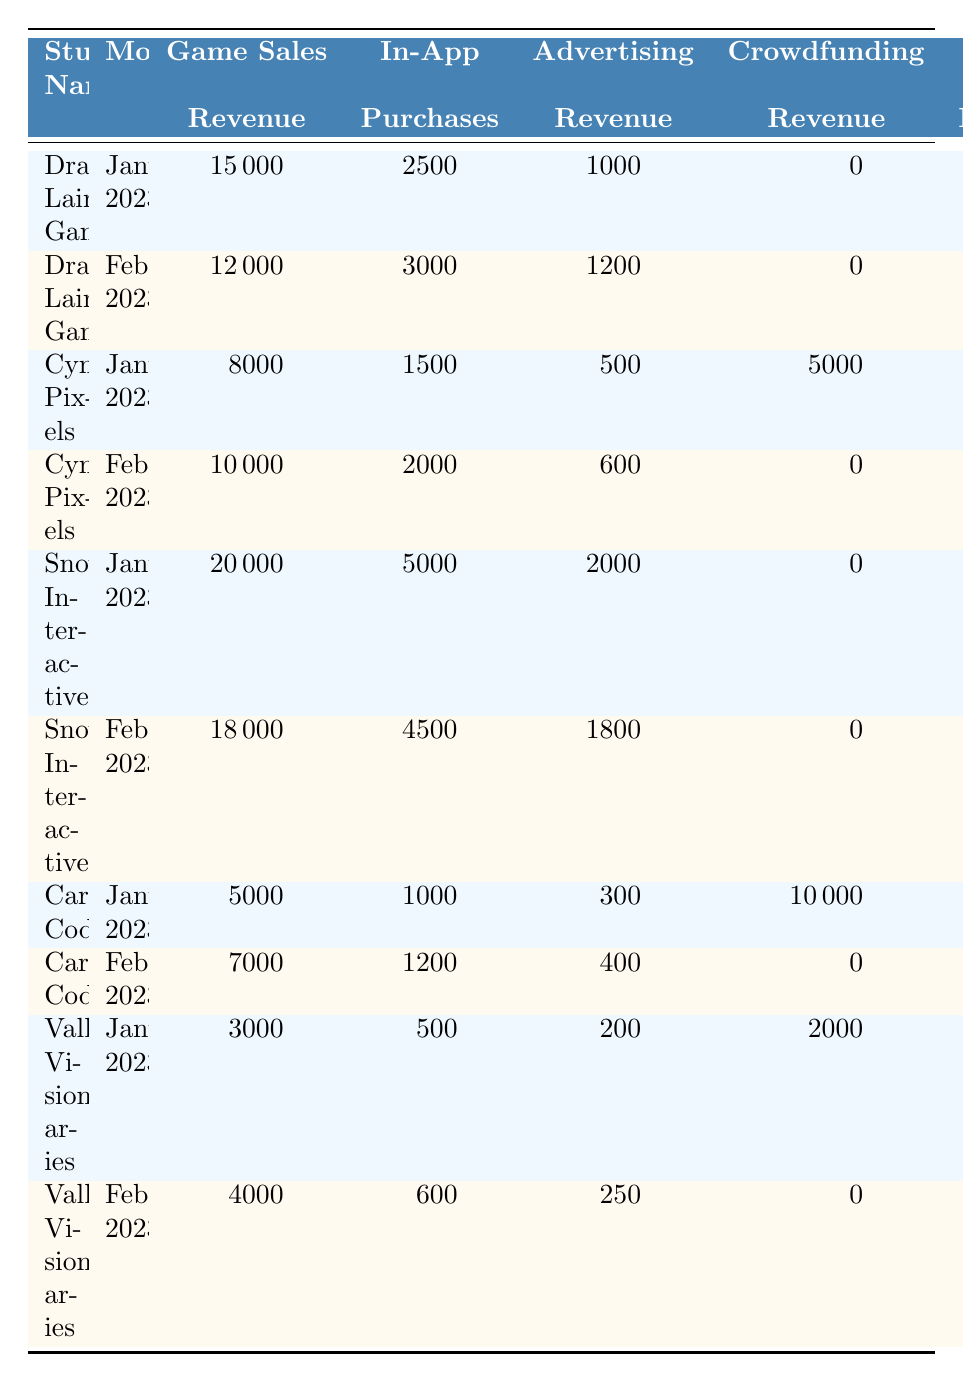What is the total revenue for Snowdonia Interactive in January 2023? The total revenue for Snowdonia Interactive in January 2023 can be found in the table under the "Total Revenue" column for that studio in that month. It is 27000.
Answer: 27000 Which studio had the highest game sales revenue in February 2023? By comparing the "Game Sales Revenue" for each studio in February 2023, Snowdonia Interactive had the highest at 18000.
Answer: Snowdonia Interactive How much revenue did Cardiff Coders generate from crowdfunding in January 2023? The crowdfunding revenue for Cardiff Coders in January 2023 is listed in the table under "Crowdfunding Revenue." It is 10000.
Answer: 10000 What was the difference in total revenue for Cymru Pixels between January and February 2023? For Cymru Pixels, the total revenue in January 2023 is 15000 and in February 2023 is 12600. The difference is calculated as 15000 - 12600 = 2400.
Answer: 2400 Did Valleys Visionaries generate more revenue from in-app purchases in January or February 2023? Valleys Visionaries made 500 in January and 600 in February from in-app purchases. Since 600 > 500, they generated more revenue in February.
Answer: Yes, more in February What is the average game sales revenue for all studios in January 2023? The game sales revenues for January from all studios are 15000 (Dragon's Lair) + 8000 (Cymru Pixels) + 20000 (Snowdonia) + 5000 (Cardiff Coders) + 3000 (Valleys Visionaries) = 50000. There are 5 studios, so the average is 50000 / 5 = 10000.
Answer: 10000 Which studio saw the largest decrease in total revenue from January to February 2023? To determine this, we compare the changes in total revenue between January (27000 for Snowdonia, 18500 for Dragon's Lair, 15000 for Cymru Pixels, 16300 for Cardiff Coders, and 5700 for Valleys Visionaries) and February revenues (24300, 16200, 12600, 8600, and 4850 respectively). The largest decrease is for Snowdonia, from 27000 to 24300, giving a change of 27000 - 24300 = 2700.
Answer: Snowdonia Interactive What was the total revenue across all studios in January 2023? We sum the total revenue for each studio in January: 18500 (Dragon's Lair) + 15000 (Cymru Pixels) + 27000 (Snowdonia) + 16300 (Cardiff Coders) + 5700 (Valleys Visionaries) = 84500.
Answer: 84500 How much more did Dragon's Lair Games make from game sales in January compared to February 2023? The game sales revenue for Dragon's Lair in January is 15000 and in February is 12000. The difference is 15000 - 12000 = 3000.
Answer: 3000 Did any studio have total revenue decline month-on-month? We compare total revenues between months for each studio: Dragon's Lair decreased from 18500 to 16200, Cymru Pixels from 15000 to 12600, Cardiff Coders from 16300 to 8600, Valleys Visionaries from 5700 to 4850, while Snowdonia increased from 27000 to 24300. Thus, yes, all except Snowdonia had declines.
Answer: Yes 